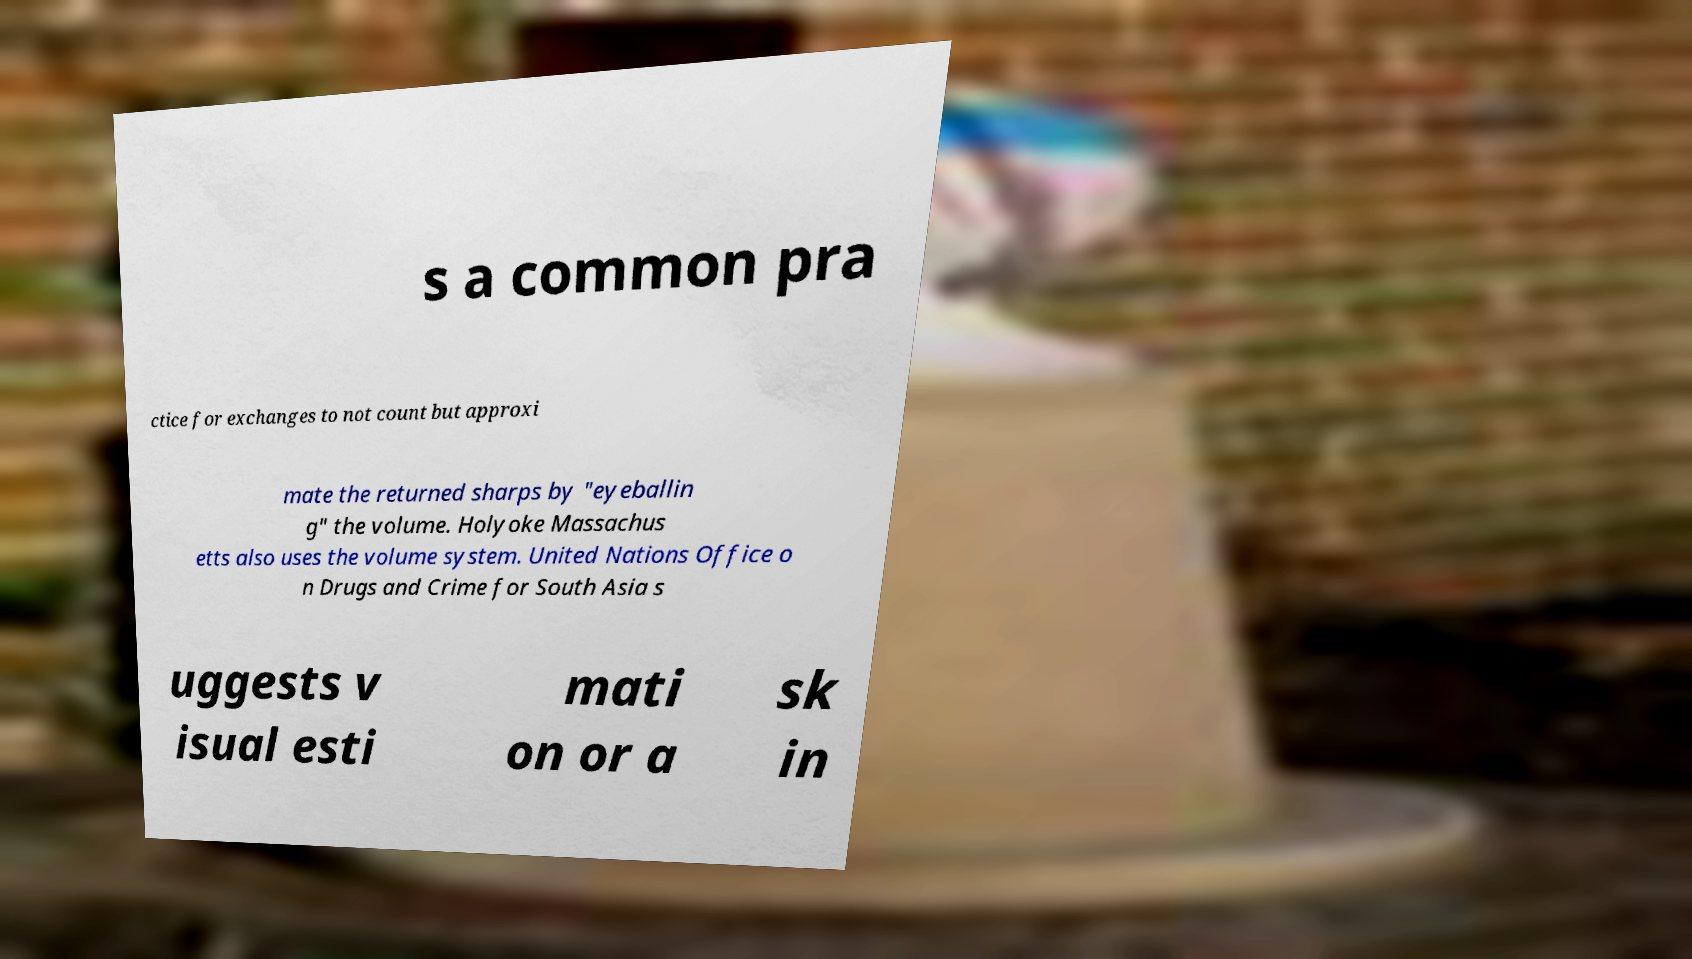Could you assist in decoding the text presented in this image and type it out clearly? s a common pra ctice for exchanges to not count but approxi mate the returned sharps by "eyeballin g" the volume. Holyoke Massachus etts also uses the volume system. United Nations Office o n Drugs and Crime for South Asia s uggests v isual esti mati on or a sk in 